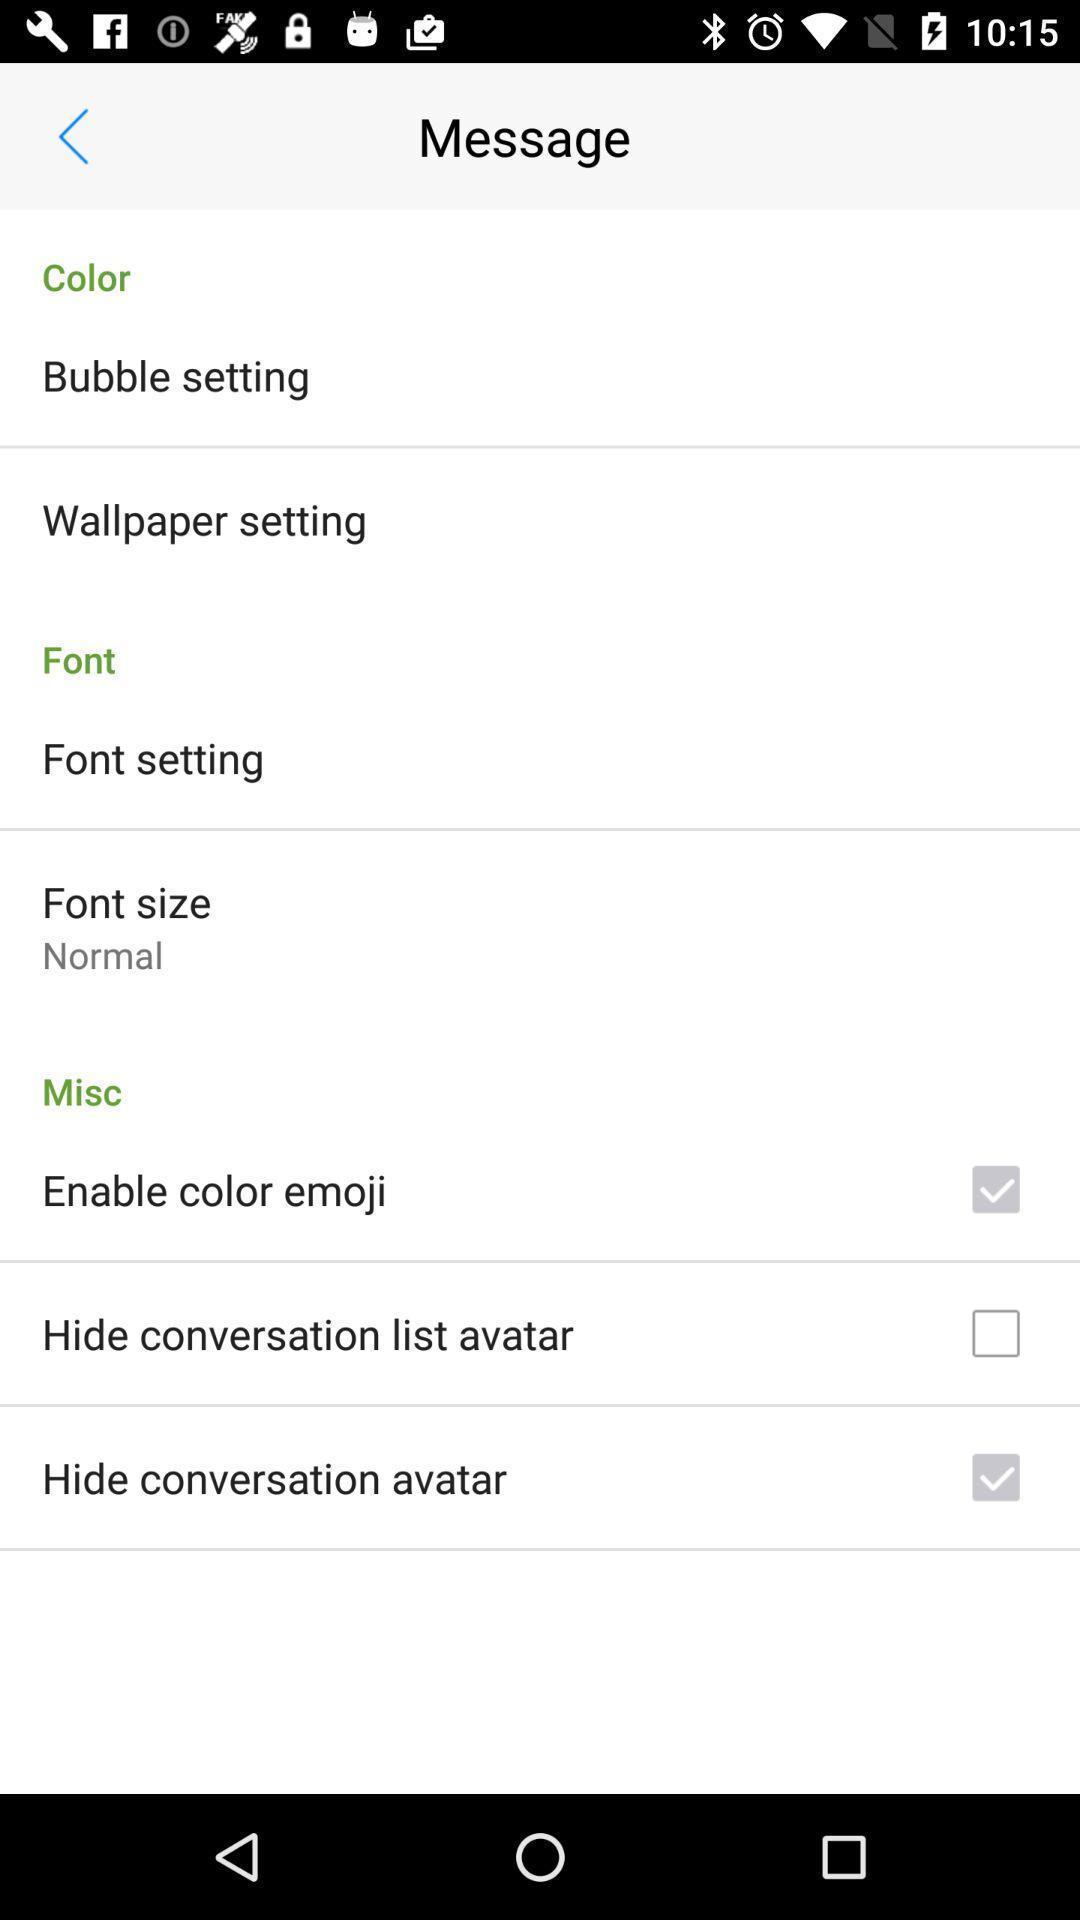Describe the key features of this screenshot. Page displaying different options available. 